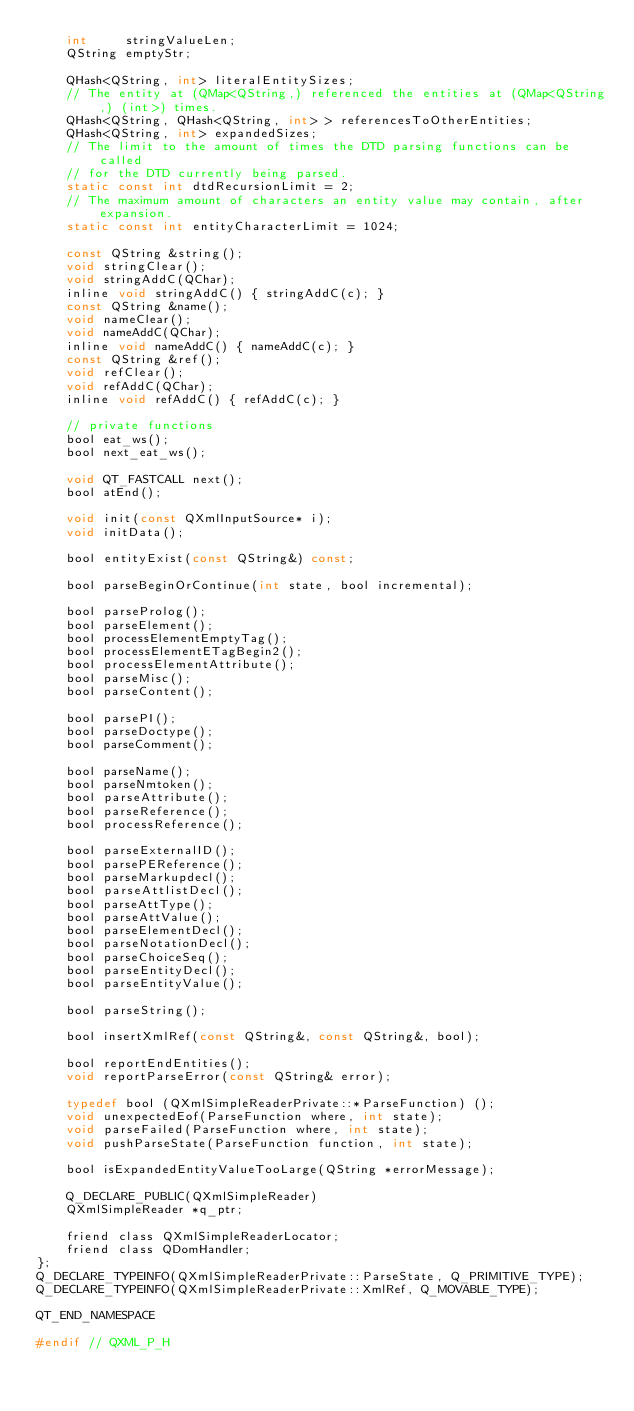<code> <loc_0><loc_0><loc_500><loc_500><_C_>    int     stringValueLen;
    QString emptyStr;

    QHash<QString, int> literalEntitySizes;
    // The entity at (QMap<QString,) referenced the entities at (QMap<QString,) (int>) times.
    QHash<QString, QHash<QString, int> > referencesToOtherEntities;
    QHash<QString, int> expandedSizes;
    // The limit to the amount of times the DTD parsing functions can be called
    // for the DTD currently being parsed.
    static const int dtdRecursionLimit = 2;
    // The maximum amount of characters an entity value may contain, after expansion.
    static const int entityCharacterLimit = 1024;

    const QString &string();
    void stringClear();
    void stringAddC(QChar);
    inline void stringAddC() { stringAddC(c); }
    const QString &name();
    void nameClear();
    void nameAddC(QChar);
    inline void nameAddC() { nameAddC(c); }
    const QString &ref();
    void refClear();
    void refAddC(QChar);
    inline void refAddC() { refAddC(c); }

    // private functions
    bool eat_ws();
    bool next_eat_ws();

    void QT_FASTCALL next();
    bool atEnd();

    void init(const QXmlInputSource* i);
    void initData();

    bool entityExist(const QString&) const;

    bool parseBeginOrContinue(int state, bool incremental);

    bool parseProlog();
    bool parseElement();
    bool processElementEmptyTag();
    bool processElementETagBegin2();
    bool processElementAttribute();
    bool parseMisc();
    bool parseContent();

    bool parsePI();
    bool parseDoctype();
    bool parseComment();

    bool parseName();
    bool parseNmtoken();
    bool parseAttribute();
    bool parseReference();
    bool processReference();

    bool parseExternalID();
    bool parsePEReference();
    bool parseMarkupdecl();
    bool parseAttlistDecl();
    bool parseAttType();
    bool parseAttValue();
    bool parseElementDecl();
    bool parseNotationDecl();
    bool parseChoiceSeq();
    bool parseEntityDecl();
    bool parseEntityValue();

    bool parseString();

    bool insertXmlRef(const QString&, const QString&, bool);

    bool reportEndEntities();
    void reportParseError(const QString& error);

    typedef bool (QXmlSimpleReaderPrivate::*ParseFunction) ();
    void unexpectedEof(ParseFunction where, int state);
    void parseFailed(ParseFunction where, int state);
    void pushParseState(ParseFunction function, int state);

    bool isExpandedEntityValueTooLarge(QString *errorMessage);

    Q_DECLARE_PUBLIC(QXmlSimpleReader)
    QXmlSimpleReader *q_ptr;

    friend class QXmlSimpleReaderLocator;
    friend class QDomHandler;
};
Q_DECLARE_TYPEINFO(QXmlSimpleReaderPrivate::ParseState, Q_PRIMITIVE_TYPE);
Q_DECLARE_TYPEINFO(QXmlSimpleReaderPrivate::XmlRef, Q_MOVABLE_TYPE);

QT_END_NAMESPACE

#endif // QXML_P_H
</code> 